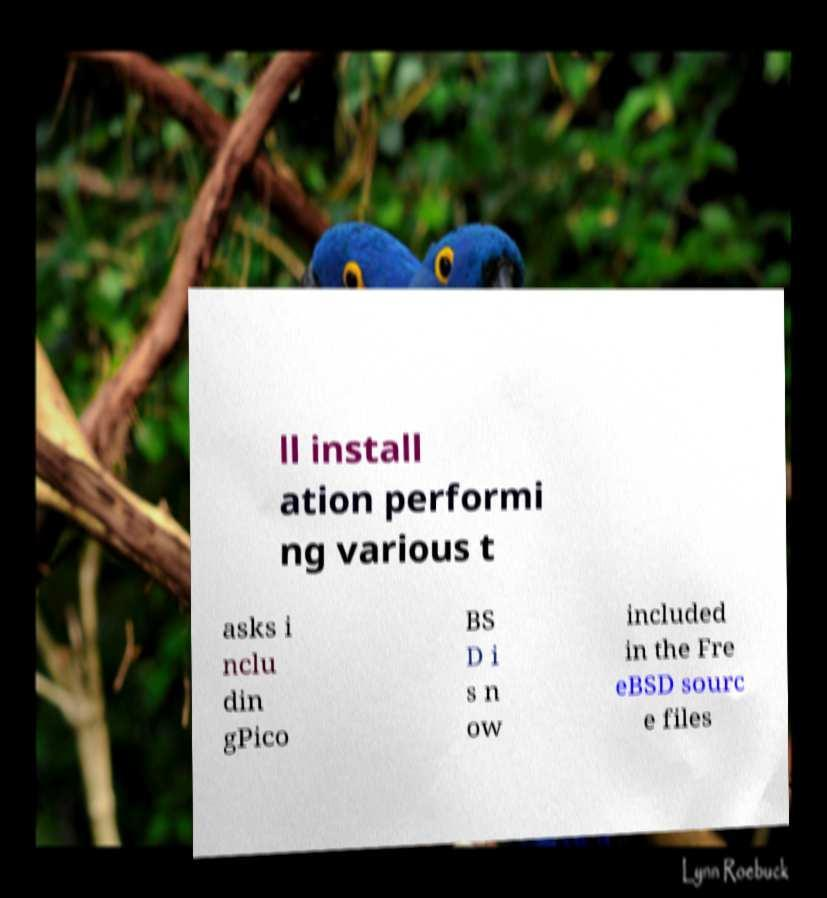Can you read and provide the text displayed in the image?This photo seems to have some interesting text. Can you extract and type it out for me? ll install ation performi ng various t asks i nclu din gPico BS D i s n ow included in the Fre eBSD sourc e files 